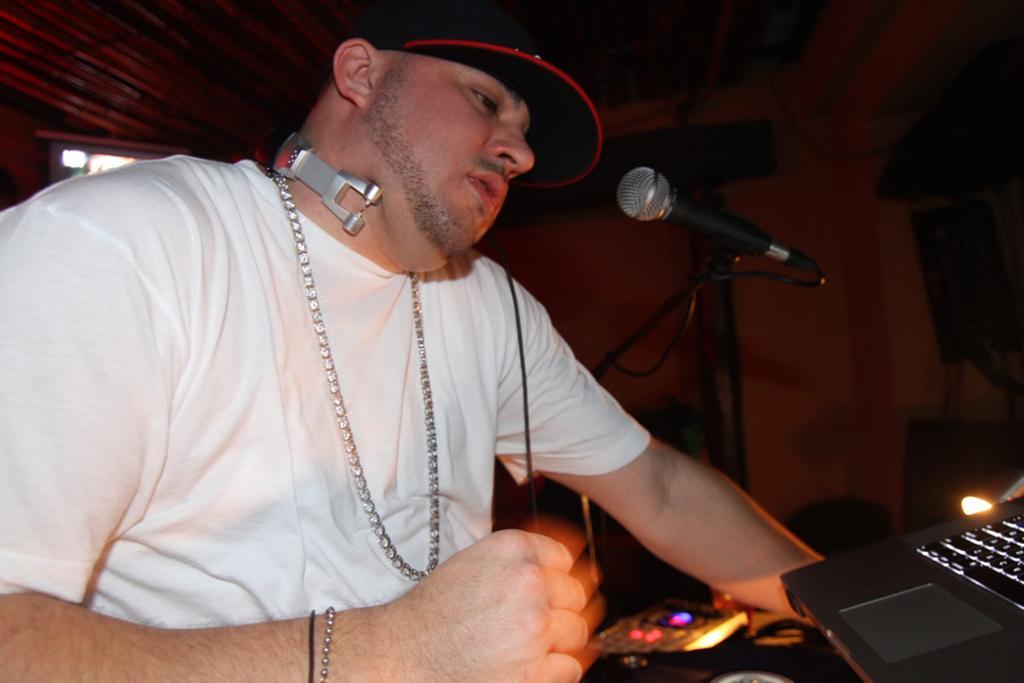How would you summarize this image in a sentence or two? In this picture we can see a man, in front of him we can find a microphone, laptop, light and other things. 